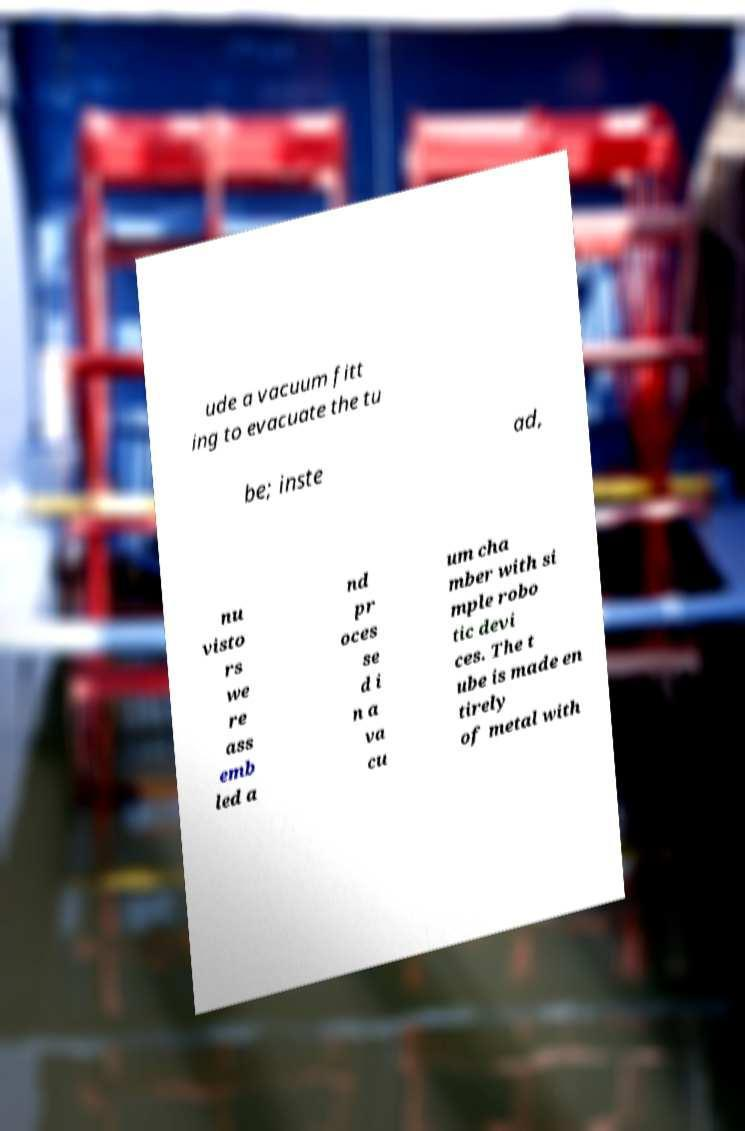I need the written content from this picture converted into text. Can you do that? ude a vacuum fitt ing to evacuate the tu be; inste ad, nu visto rs we re ass emb led a nd pr oces se d i n a va cu um cha mber with si mple robo tic devi ces. The t ube is made en tirely of metal with 